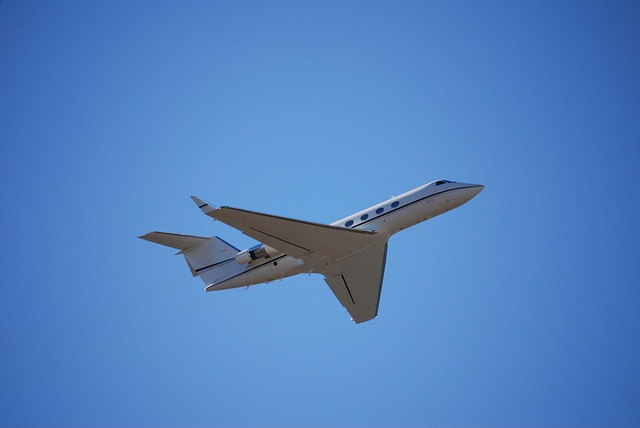Describe the objects in this image and their specific colors. I can see a airplane in blue, gray, black, and darkgray tones in this image. 